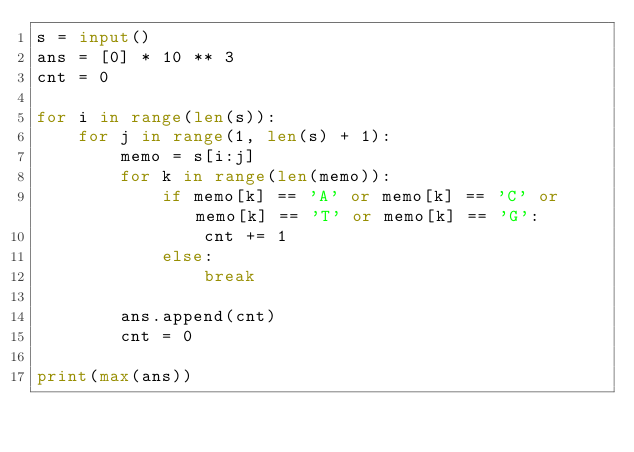Convert code to text. <code><loc_0><loc_0><loc_500><loc_500><_Python_>s = input()
ans = [0] * 10 ** 3
cnt = 0

for i in range(len(s)):
    for j in range(1, len(s) + 1):
        memo = s[i:j]
        for k in range(len(memo)):
            if memo[k] == 'A' or memo[k] == 'C' or memo[k] == 'T' or memo[k] == 'G':
                cnt += 1
            else:
                break

        ans.append(cnt)
        cnt = 0

print(max(ans))
</code> 